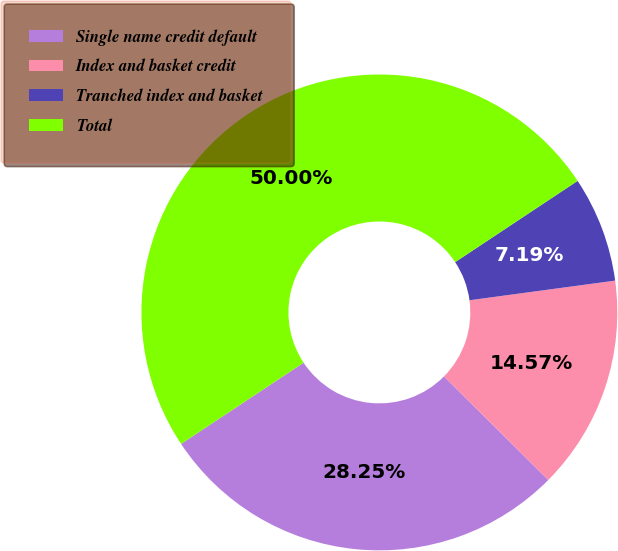Convert chart to OTSL. <chart><loc_0><loc_0><loc_500><loc_500><pie_chart><fcel>Single name credit default<fcel>Index and basket credit<fcel>Tranched index and basket<fcel>Total<nl><fcel>28.25%<fcel>14.57%<fcel>7.19%<fcel>50.0%<nl></chart> 